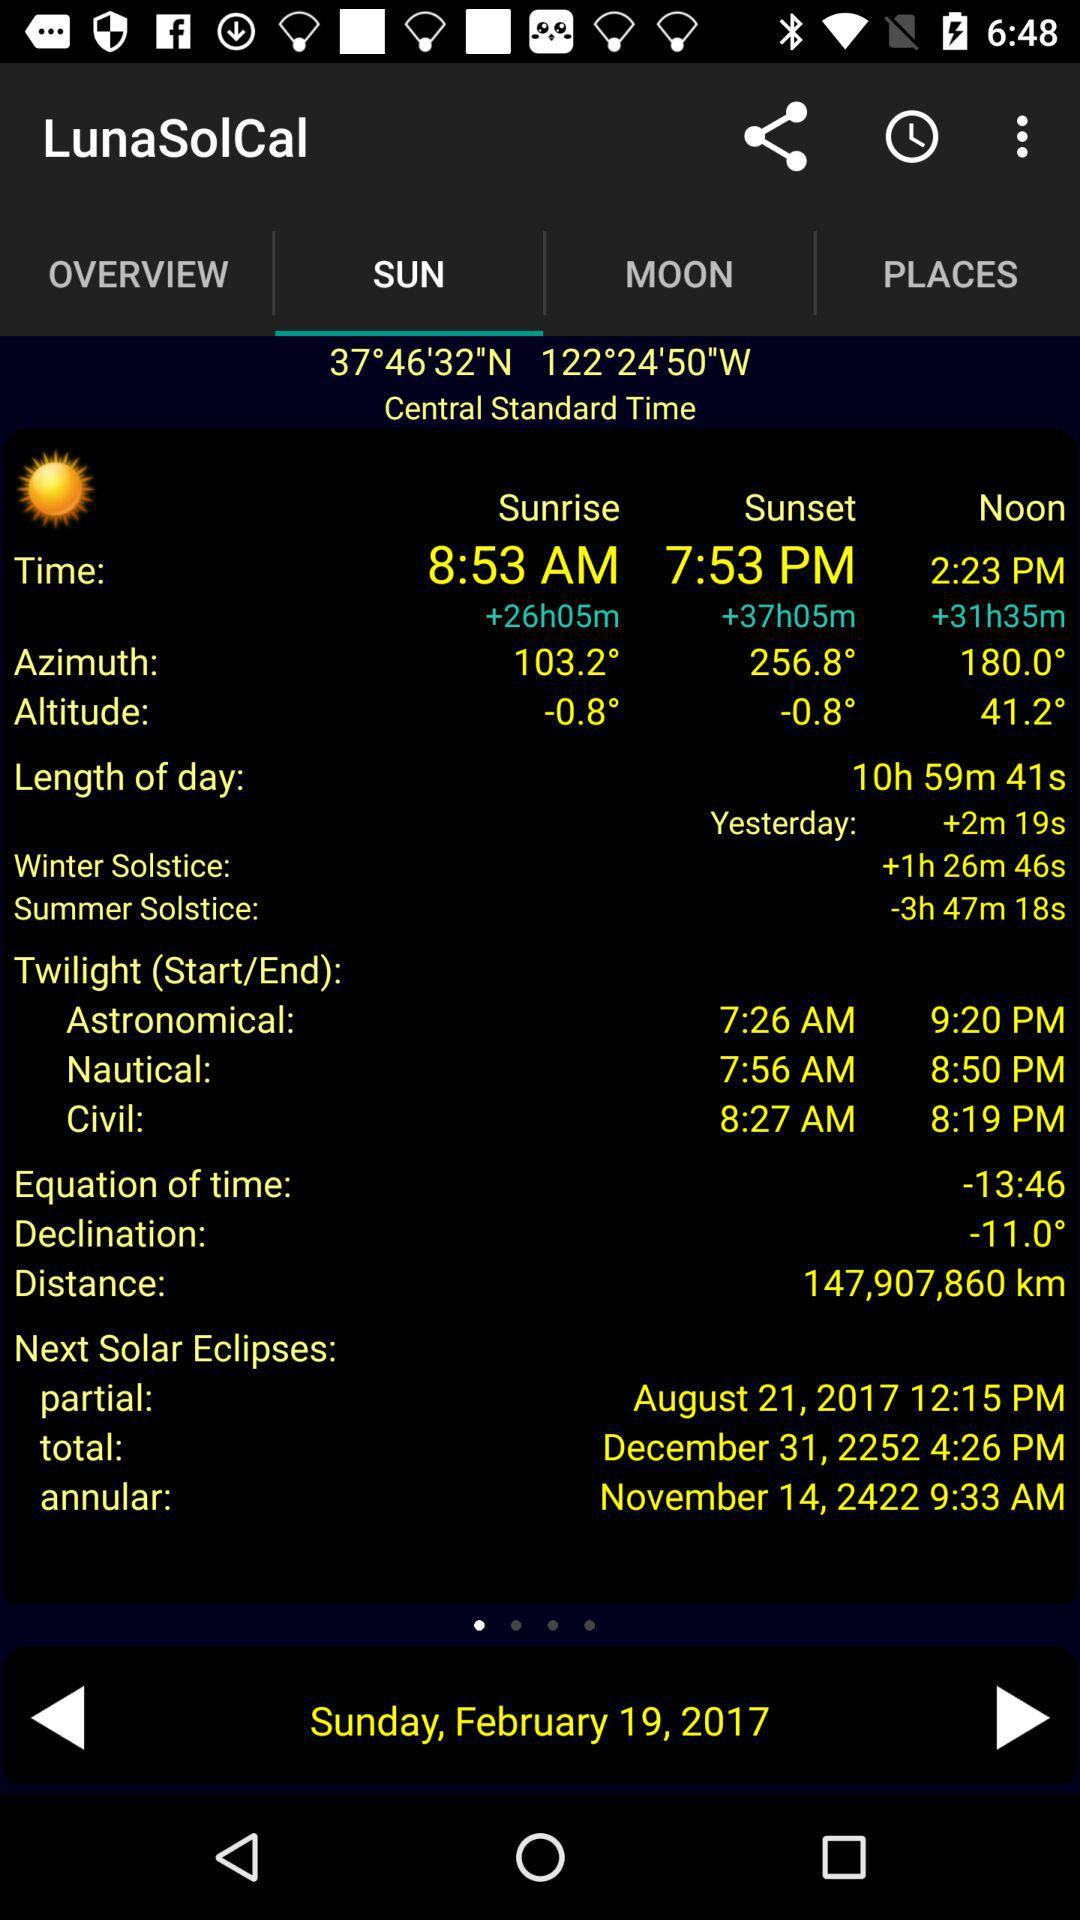What is the time of noon? The time of noon is 2:23 PM. 